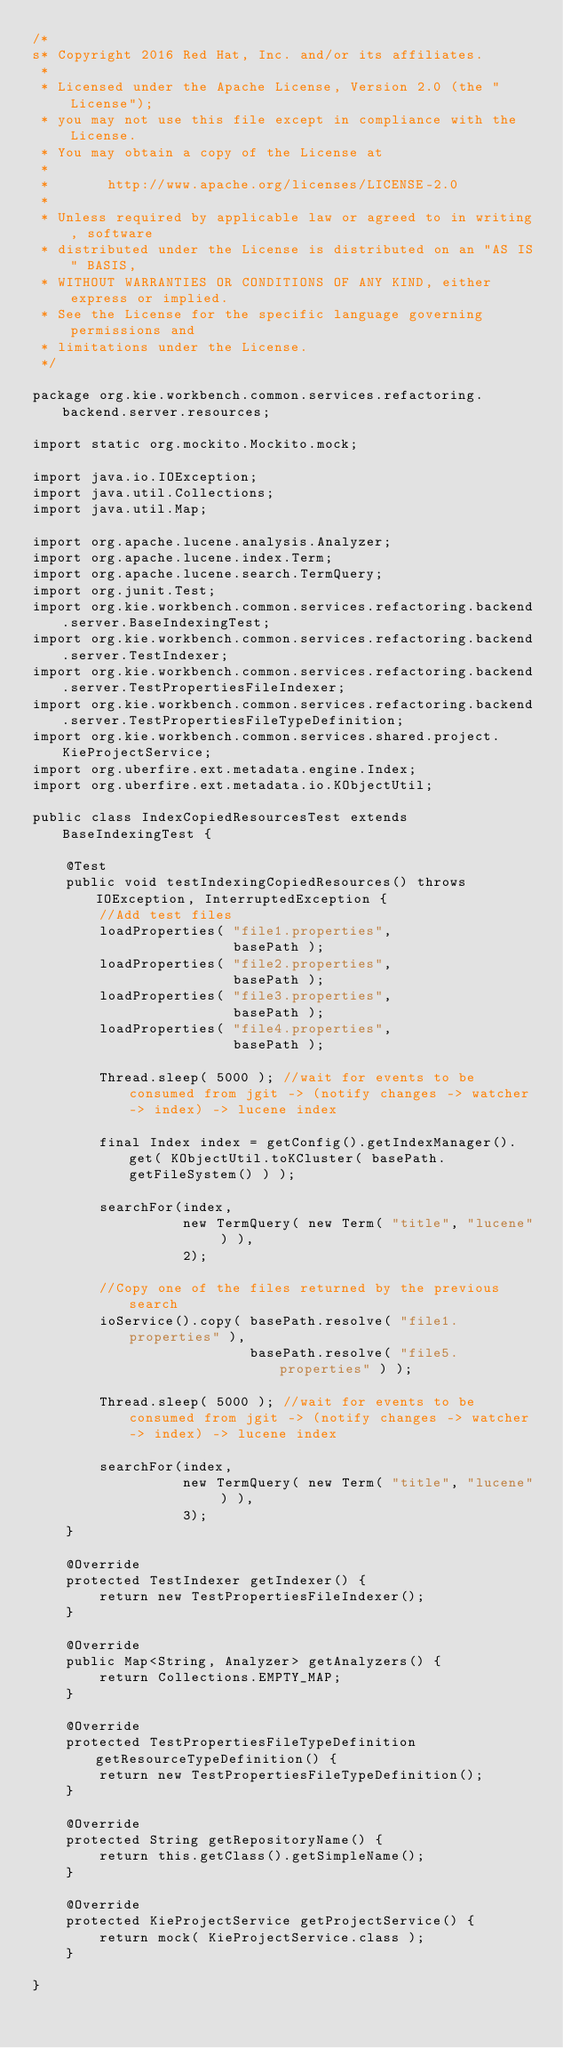Convert code to text. <code><loc_0><loc_0><loc_500><loc_500><_Java_>/*
s* Copyright 2016 Red Hat, Inc. and/or its affiliates.
 *
 * Licensed under the Apache License, Version 2.0 (the "License");
 * you may not use this file except in compliance with the License.
 * You may obtain a copy of the License at
 *
 *       http://www.apache.org/licenses/LICENSE-2.0
 *
 * Unless required by applicable law or agreed to in writing, software
 * distributed under the License is distributed on an "AS IS" BASIS,
 * WITHOUT WARRANTIES OR CONDITIONS OF ANY KIND, either express or implied.
 * See the License for the specific language governing permissions and
 * limitations under the License.
 */

package org.kie.workbench.common.services.refactoring.backend.server.resources;

import static org.mockito.Mockito.mock;

import java.io.IOException;
import java.util.Collections;
import java.util.Map;

import org.apache.lucene.analysis.Analyzer;
import org.apache.lucene.index.Term;
import org.apache.lucene.search.TermQuery;
import org.junit.Test;
import org.kie.workbench.common.services.refactoring.backend.server.BaseIndexingTest;
import org.kie.workbench.common.services.refactoring.backend.server.TestIndexer;
import org.kie.workbench.common.services.refactoring.backend.server.TestPropertiesFileIndexer;
import org.kie.workbench.common.services.refactoring.backend.server.TestPropertiesFileTypeDefinition;
import org.kie.workbench.common.services.shared.project.KieProjectService;
import org.uberfire.ext.metadata.engine.Index;
import org.uberfire.ext.metadata.io.KObjectUtil;

public class IndexCopiedResourcesTest extends BaseIndexingTest {

    @Test
    public void testIndexingCopiedResources() throws IOException, InterruptedException {
        //Add test files
        loadProperties( "file1.properties",
                        basePath );
        loadProperties( "file2.properties",
                        basePath );
        loadProperties( "file3.properties",
                        basePath );
        loadProperties( "file4.properties",
                        basePath );

        Thread.sleep( 5000 ); //wait for events to be consumed from jgit -> (notify changes -> watcher -> index) -> lucene index

        final Index index = getConfig().getIndexManager().get( KObjectUtil.toKCluster( basePath.getFileSystem() ) );

        searchFor(index,
                  new TermQuery( new Term( "title", "lucene" ) ),
                  2);

        //Copy one of the files returned by the previous search
        ioService().copy( basePath.resolve( "file1.properties" ),
                          basePath.resolve( "file5.properties" ) );

        Thread.sleep( 5000 ); //wait for events to be consumed from jgit -> (notify changes -> watcher -> index) -> lucene index

        searchFor(index,
                  new TermQuery( new Term( "title", "lucene" ) ),
                  3);
    }

    @Override
    protected TestIndexer getIndexer() {
        return new TestPropertiesFileIndexer();
    }

    @Override
    public Map<String, Analyzer> getAnalyzers() {
        return Collections.EMPTY_MAP;
    }

    @Override
    protected TestPropertiesFileTypeDefinition getResourceTypeDefinition() {
        return new TestPropertiesFileTypeDefinition();
    }

    @Override
    protected String getRepositoryName() {
        return this.getClass().getSimpleName();
    }

    @Override
    protected KieProjectService getProjectService() {
        return mock( KieProjectService.class );
    }

}
</code> 